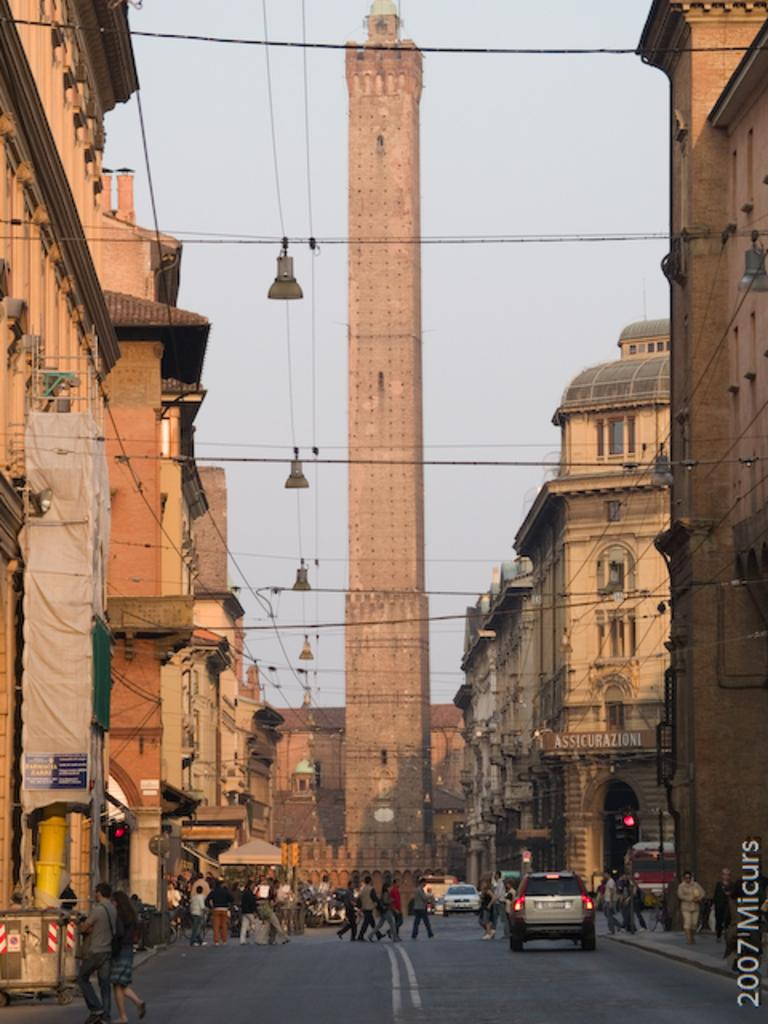What is the main structure in the center of the image? There is a tower in the center of the image. What can be seen on either side of the tower? There are buildings on both sides of the image. What is at the bottom of the image? There is a road at the bottom of the image. What are the people in the image doing? People are walking in the image. What type of vehicles are present in the image? Cars are present in the image. Can you see any patches of grass growing on the tower in the image? There are no patches of grass visible on the tower in the image. Did an earthquake cause the buildings to collapse in the image? There is no indication of any damage or collapse to the buildings in the image. 